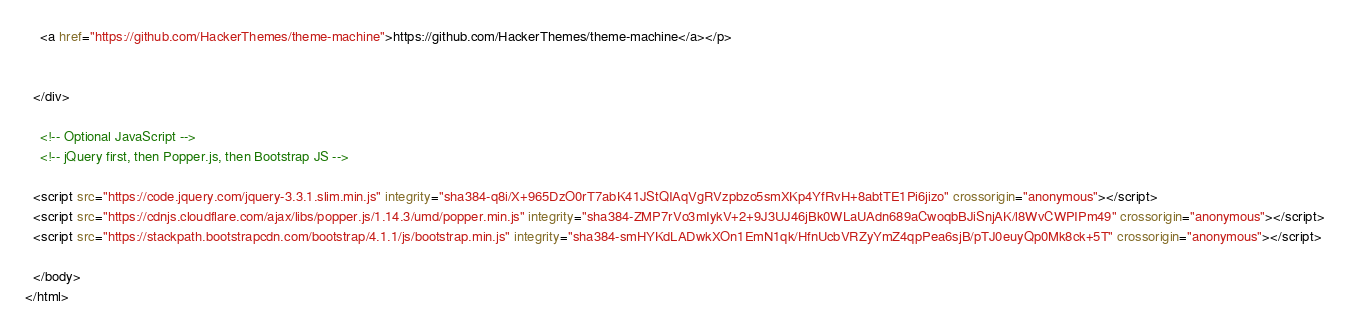Convert code to text. <code><loc_0><loc_0><loc_500><loc_500><_HTML_>    <a href="https://github.com/HackerThemes/theme-machine">https://github.com/HackerThemes/theme-machine</a></p>

   
  </div>

    <!-- Optional JavaScript -->
    <!-- jQuery first, then Popper.js, then Bootstrap JS -->

  <script src="https://code.jquery.com/jquery-3.3.1.slim.min.js" integrity="sha384-q8i/X+965DzO0rT7abK41JStQIAqVgRVzpbzo5smXKp4YfRvH+8abtTE1Pi6jizo" crossorigin="anonymous"></script>
  <script src="https://cdnjs.cloudflare.com/ajax/libs/popper.js/1.14.3/umd/popper.min.js" integrity="sha384-ZMP7rVo3mIykV+2+9J3UJ46jBk0WLaUAdn689aCwoqbBJiSnjAK/l8WvCWPIPm49" crossorigin="anonymous"></script>
  <script src="https://stackpath.bootstrapcdn.com/bootstrap/4.1.1/js/bootstrap.min.js" integrity="sha384-smHYKdLADwkXOn1EmN1qk/HfnUcbVRZyYmZ4qpPea6sjB/pTJ0euyQp0Mk8ck+5T" crossorigin="anonymous"></script>

  </body>
</html>
</code> 